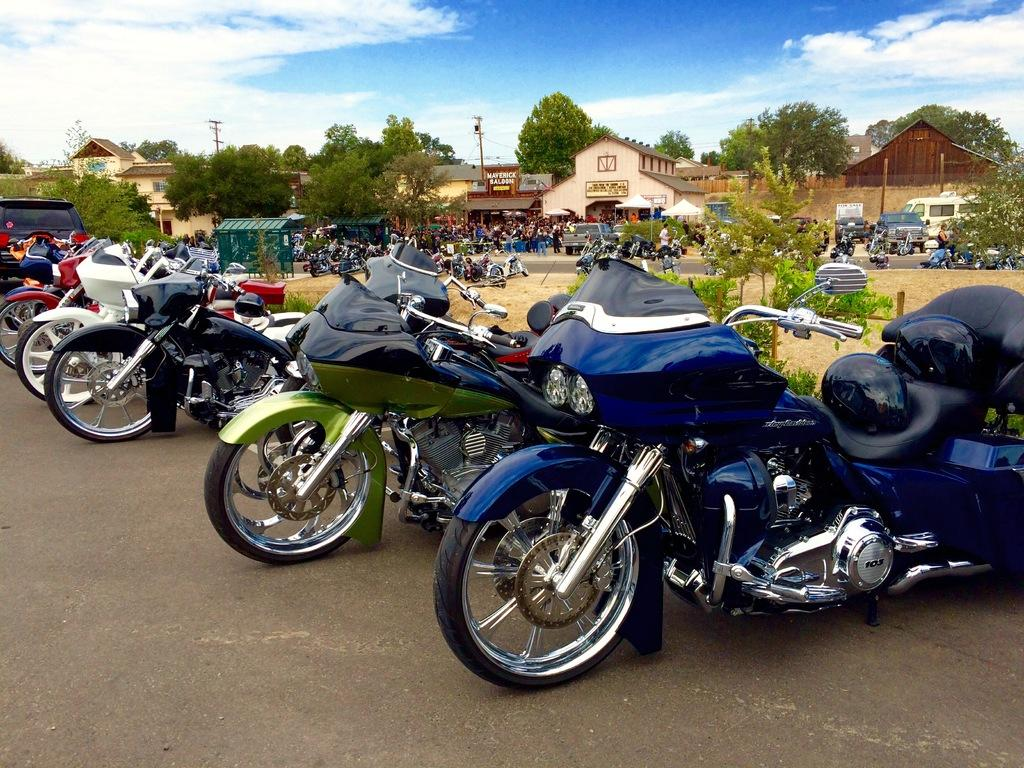What type of vehicles are present in the image? There are motorcycles in the image. What structures can be seen in the image? There are buildings in the image. Who or what is present in the image? There are people in the image. What type of vegetation is visible in the image? There are trees in the image. What utility infrastructure is present in the image? There are current poles in the image. What is visible at the top of the image? The sky is visible at the top of the image. What type of brush is being used by the people in the image? There is no brush visible in the image; the people are not engaged in any activity that would require a brush. How many sticks are being held by the motorcycles in the image? There are no sticks present in the image; the motorcycles are not holding any objects. 